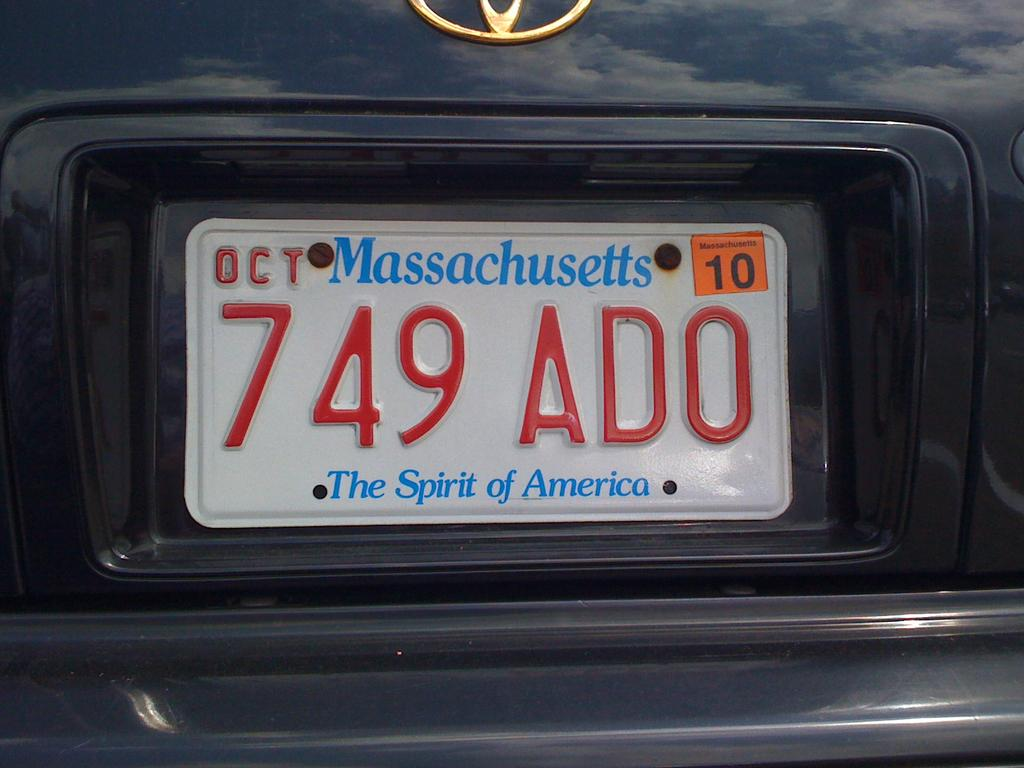<image>
Share a concise interpretation of the image provided. A Massachusetts license plate with their motto the Spirit of America. 